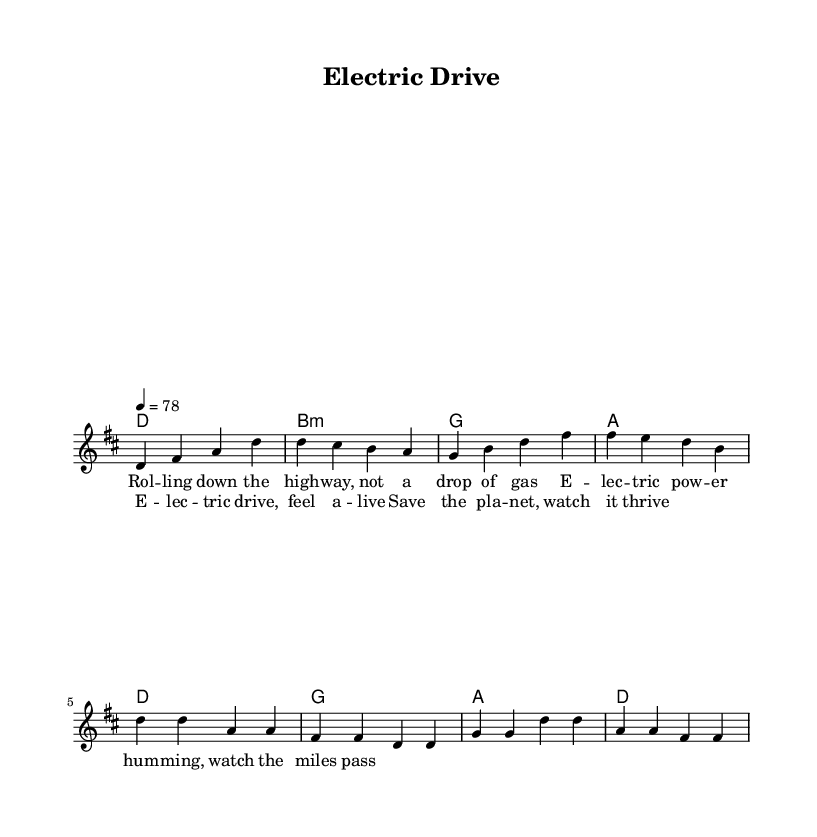What is the key signature of this music? The key signature is indicated at the beginning of the staff. It shows two sharps, which indicates that the key is D major.
Answer: D major What is the time signature of this music? The time signature is found at the beginning of the staff as well. It is written as 4/4, meaning there are four beats in each measure.
Answer: 4/4 What is the tempo marking in this piece? The tempo is specified with the marking "4 = 78" indicating that there are 78 beats per minute for each quarter note.
Answer: 78 How many measures are there in the verse? The verse is comprised of four measures, as counted by the vertical lines separating the measures in the sheet music.
Answer: 4 What is the tonic chord used in the chorus? The tonic chord is the first chord in the chorus, which is indicated as D major based on the chord symbols above the melody line.
Answer: D What is the theme of the lyrics in this piece? The theme can be interpreted by reading the lyrics provided, which revolve around electric power and sustainability. The lyrics express a positive outlook on electric transportation.
Answer: Sustainability How many different chords are used throughout the score? By analyzing the chords listed in the harmonic section, there are four different chords: D, B minor, G, and A, which are played throughout the piece.
Answer: 4 